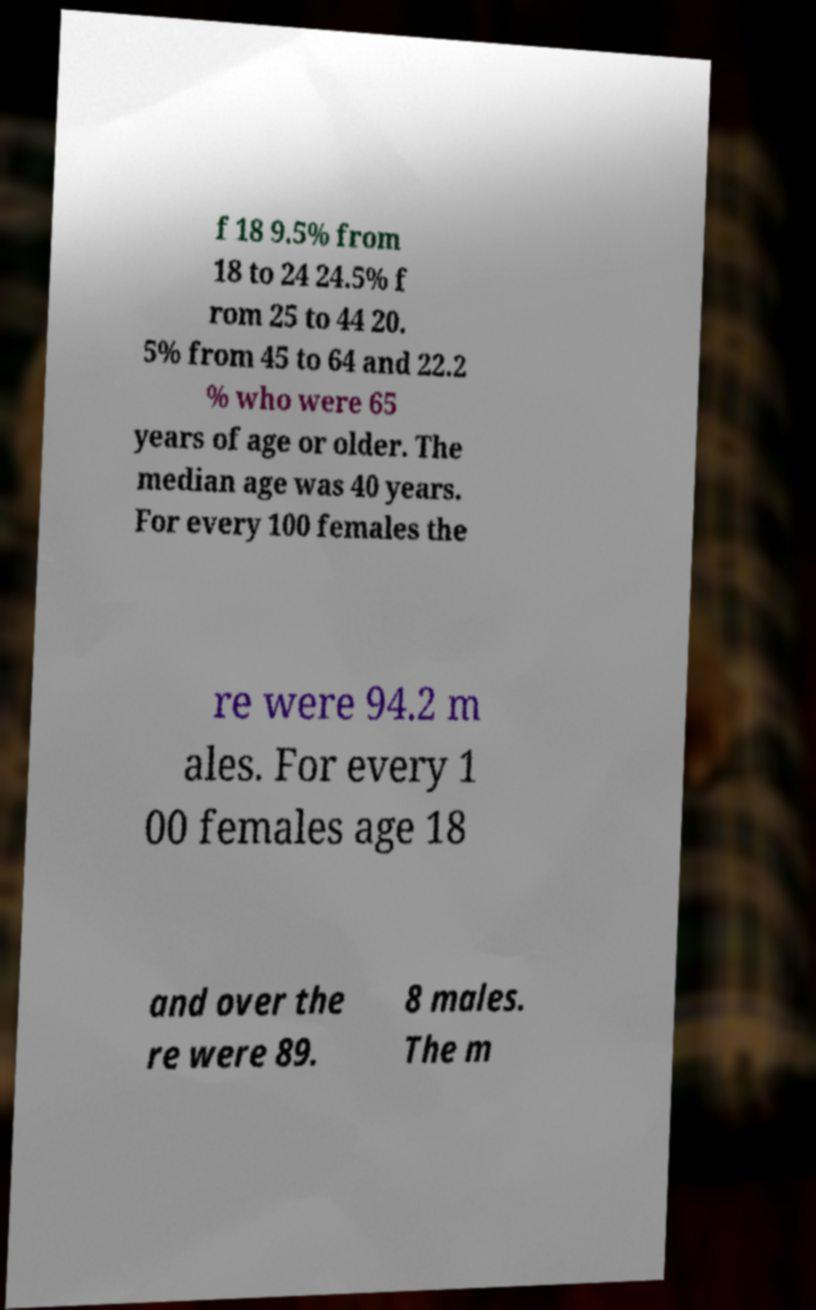Please read and relay the text visible in this image. What does it say? f 18 9.5% from 18 to 24 24.5% f rom 25 to 44 20. 5% from 45 to 64 and 22.2 % who were 65 years of age or older. The median age was 40 years. For every 100 females the re were 94.2 m ales. For every 1 00 females age 18 and over the re were 89. 8 males. The m 